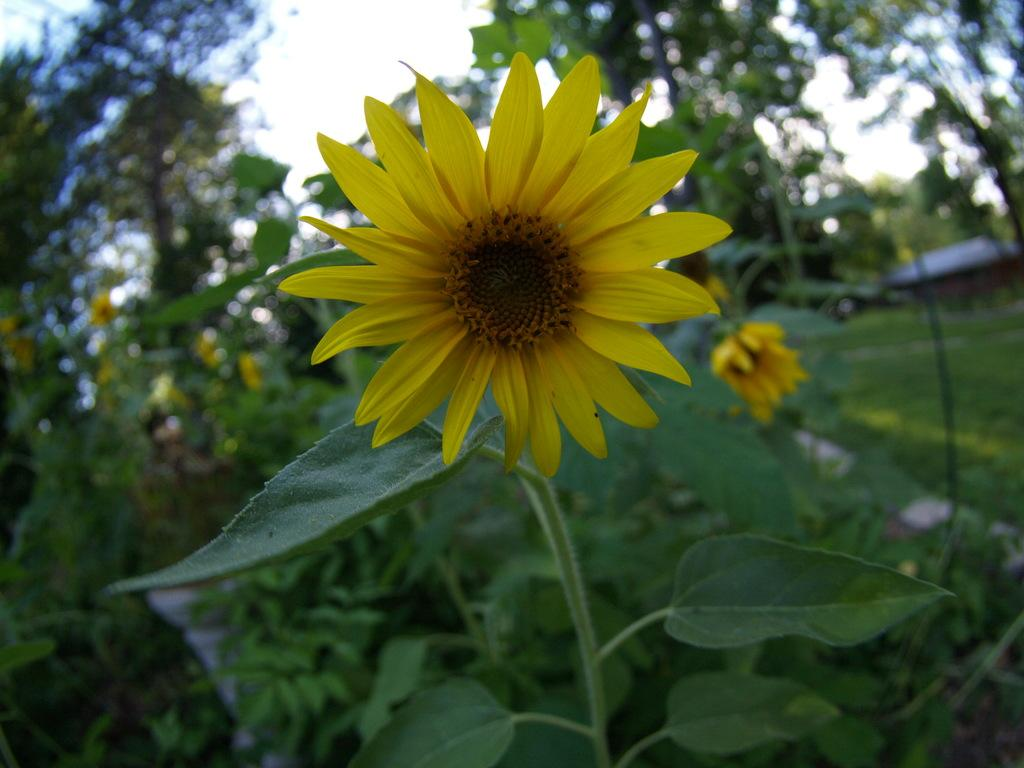What is the main subject in the center of the image? There is a sunflower in the center of the image. What can be seen in the background of the image? There are plants and flowers in the background of the image. Reasoning: Let's think step by identifying the main subject and objects in the image based on the provided facts. We then formulate questions that focus on the location and characteristics of these subjects and objects, ensuring that each question can be answered definitively with the information given. We avoid yes/no questions and ensure that the language is simple and clear. Absurd Question/Answer: What invention is being demonstrated in the image? There is no invention being demonstrated in the image; it features a sunflower and plants in the background. How many times does the person need to lift the flower in the image? There is no person lifting a flower in the image; it features a sunflower and plants in the background. What trick is being performed with the flowers in the image? There is no trick being performed with the flowers in the image; it features a sunflower and plants in the background. 